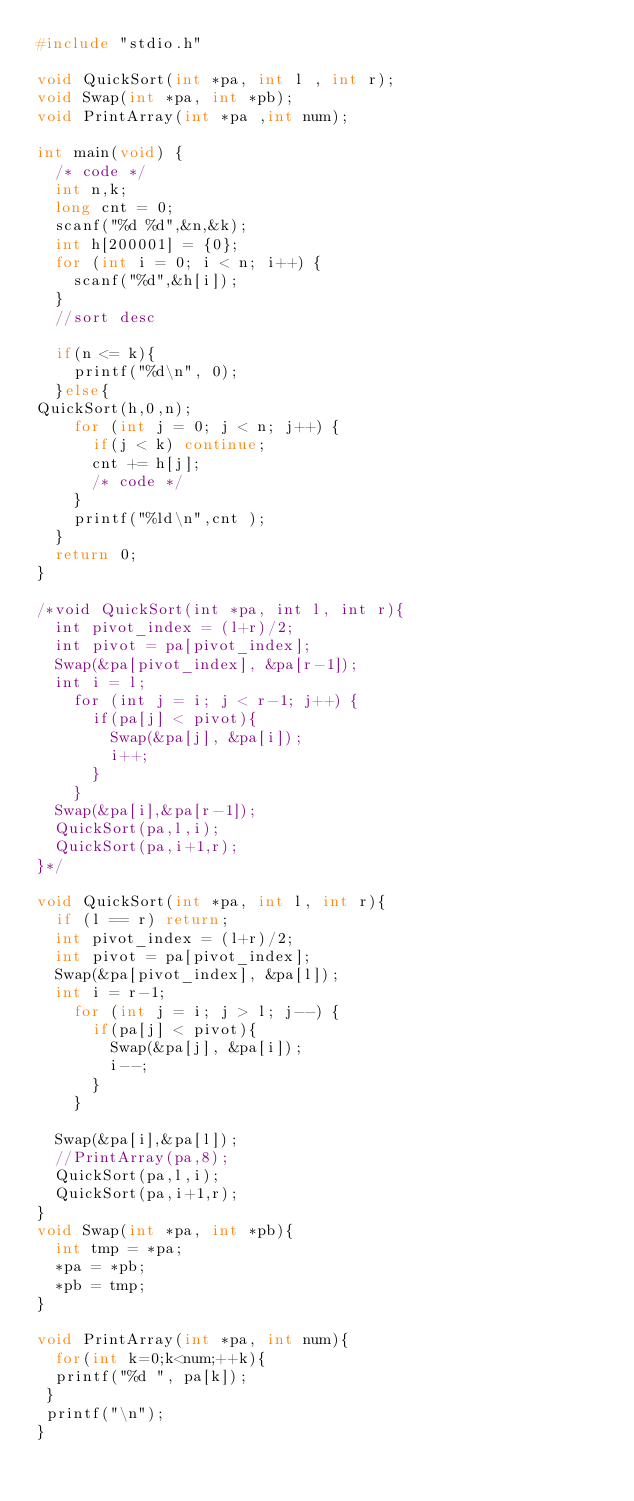<code> <loc_0><loc_0><loc_500><loc_500><_C_>#include "stdio.h"

void QuickSort(int *pa, int l , int r);
void Swap(int *pa, int *pb);
void PrintArray(int *pa ,int num);

int main(void) {
  /* code */
  int n,k;
  long cnt = 0;
  scanf("%d %d",&n,&k);
  int h[200001] = {0};
  for (int i = 0; i < n; i++) {
    scanf("%d",&h[i]);
  }
  //sort desc

  if(n <= k){
    printf("%d\n", 0);
  }else{
QuickSort(h,0,n);
    for (int j = 0; j < n; j++) {
      if(j < k) continue;
      cnt += h[j];
      /* code */
    }
    printf("%ld\n",cnt );
  }
  return 0;
}

/*void QuickSort(int *pa, int l, int r){
  int pivot_index = (l+r)/2;
  int pivot = pa[pivot_index];
  Swap(&pa[pivot_index], &pa[r-1]);
  int i = l;
    for (int j = i; j < r-1; j++) {
      if(pa[j] < pivot){
        Swap(&pa[j], &pa[i]);
        i++;
      }
    }
  Swap(&pa[i],&pa[r-1]);
  QuickSort(pa,l,i);
  QuickSort(pa,i+1,r);
}*/

void QuickSort(int *pa, int l, int r){
  if (l == r) return;
  int pivot_index = (l+r)/2;
  int pivot = pa[pivot_index];
  Swap(&pa[pivot_index], &pa[l]);
  int i = r-1;
    for (int j = i; j > l; j--) {
      if(pa[j] < pivot){
        Swap(&pa[j], &pa[i]);
        i--;
      }
    }
      
  Swap(&pa[i],&pa[l]);
  //PrintArray(pa,8);
  QuickSort(pa,l,i);
  QuickSort(pa,i+1,r);
}
void Swap(int *pa, int *pb){
  int tmp = *pa;
  *pa = *pb;
  *pb = tmp;
}

void PrintArray(int *pa, int num){
  for(int k=0;k<num;++k){
  printf("%d ", pa[k]);
 }
 printf("\n");
}
</code> 